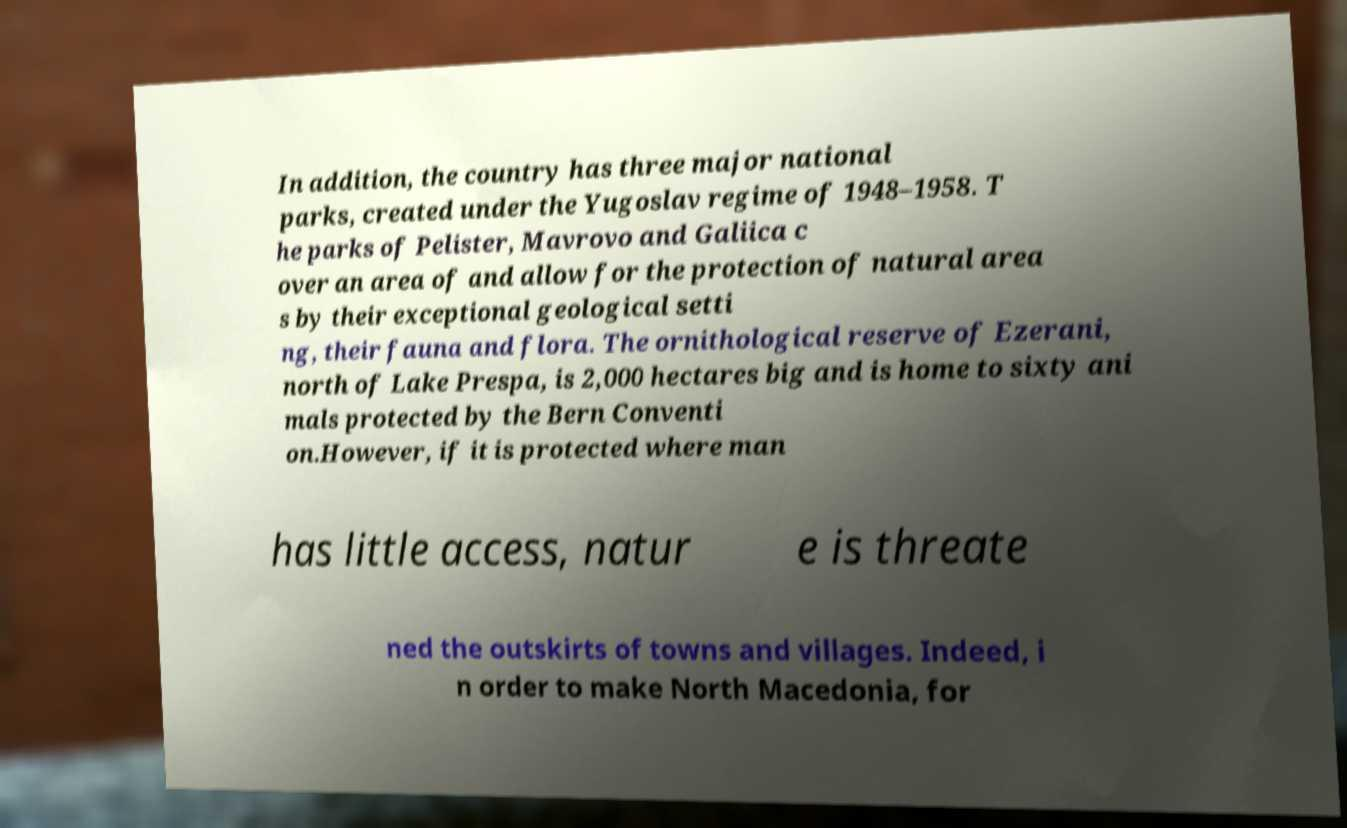Can you accurately transcribe the text from the provided image for me? In addition, the country has three major national parks, created under the Yugoslav regime of 1948–1958. T he parks of Pelister, Mavrovo and Galiica c over an area of and allow for the protection of natural area s by their exceptional geological setti ng, their fauna and flora. The ornithological reserve of Ezerani, north of Lake Prespa, is 2,000 hectares big and is home to sixty ani mals protected by the Bern Conventi on.However, if it is protected where man has little access, natur e is threate ned the outskirts of towns and villages. Indeed, i n order to make North Macedonia, for 